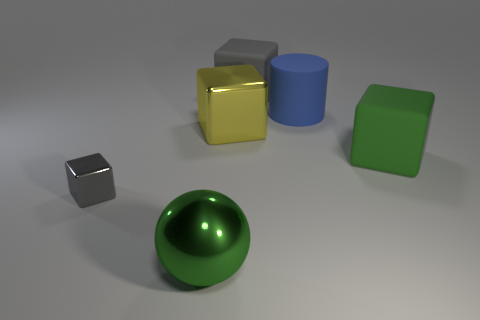Add 4 large gray rubber cubes. How many objects exist? 10 Subtract all cylinders. How many objects are left? 5 Subtract all big gray rubber things. Subtract all big matte blocks. How many objects are left? 3 Add 2 large blocks. How many large blocks are left? 5 Add 4 tiny blocks. How many tiny blocks exist? 5 Subtract 0 cyan cylinders. How many objects are left? 6 